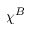<formula> <loc_0><loc_0><loc_500><loc_500>\chi ^ { B }</formula> 